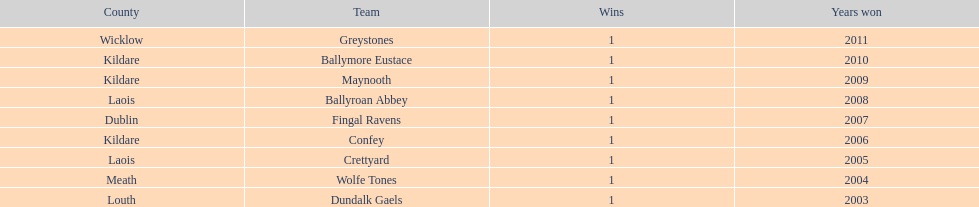What is the number of wins for confey 1. 